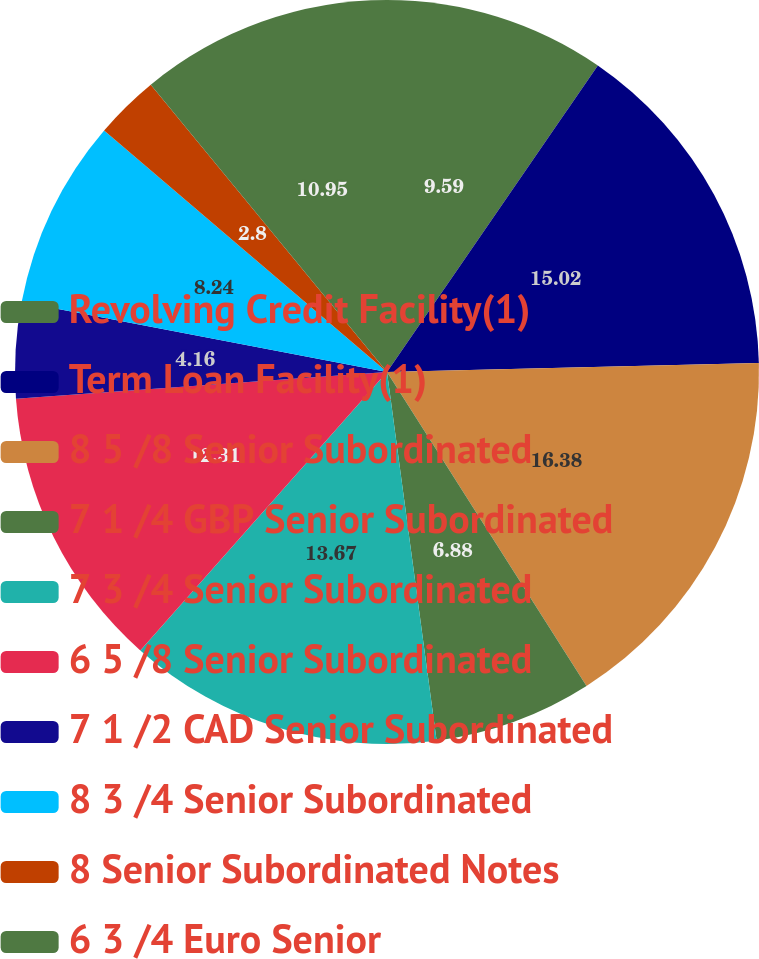Convert chart to OTSL. <chart><loc_0><loc_0><loc_500><loc_500><pie_chart><fcel>Revolving Credit Facility(1)<fcel>Term Loan Facility(1)<fcel>8 5 /8 Senior Subordinated<fcel>7 1 /4 GBP Senior Subordinated<fcel>7 3 /4 Senior Subordinated<fcel>6 5 /8 Senior Subordinated<fcel>7 1 /2 CAD Senior Subordinated<fcel>8 3 /4 Senior Subordinated<fcel>8 Senior Subordinated Notes<fcel>6 3 /4 Euro Senior<nl><fcel>9.59%<fcel>15.02%<fcel>16.38%<fcel>6.88%<fcel>13.67%<fcel>12.31%<fcel>4.16%<fcel>8.24%<fcel>2.8%<fcel>10.95%<nl></chart> 